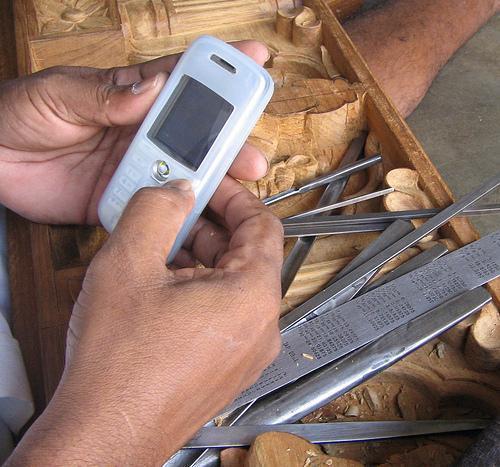How many people are there?
Give a very brief answer. 2. How many knives are in the photo?
Give a very brief answer. 2. 